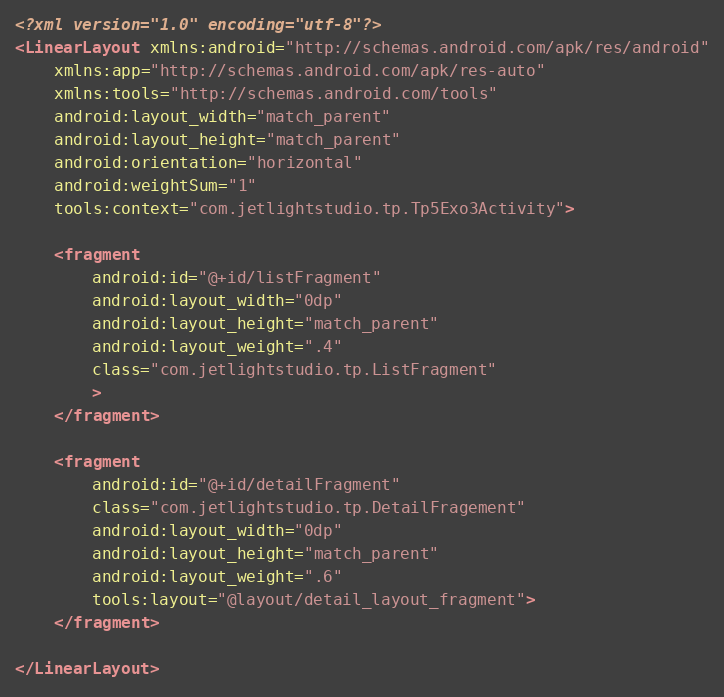Convert code to text. <code><loc_0><loc_0><loc_500><loc_500><_XML_><?xml version="1.0" encoding="utf-8"?>
<LinearLayout xmlns:android="http://schemas.android.com/apk/res/android"
    xmlns:app="http://schemas.android.com/apk/res-auto"
    xmlns:tools="http://schemas.android.com/tools"
    android:layout_width="match_parent"
    android:layout_height="match_parent"
    android:orientation="horizontal"
    android:weightSum="1"
    tools:context="com.jetlightstudio.tp.Tp5Exo3Activity">

    <fragment
        android:id="@+id/listFragment"
        android:layout_width="0dp"
        android:layout_height="match_parent"
        android:layout_weight=".4"
        class="com.jetlightstudio.tp.ListFragment"
        >
    </fragment>

    <fragment
        android:id="@+id/detailFragment"
        class="com.jetlightstudio.tp.DetailFragement"
        android:layout_width="0dp"
        android:layout_height="match_parent"
        android:layout_weight=".6"
        tools:layout="@layout/detail_layout_fragment">
    </fragment>

</LinearLayout>
</code> 